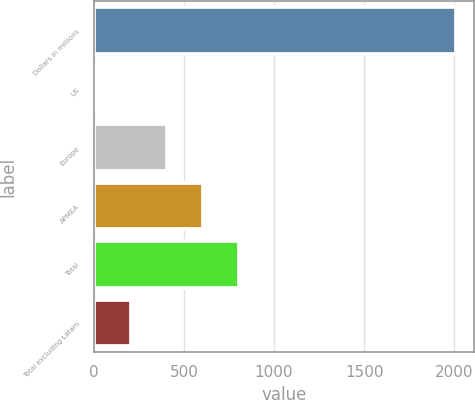Convert chart to OTSL. <chart><loc_0><loc_0><loc_500><loc_500><bar_chart><fcel>Dollars in millions<fcel>US<fcel>Europe<fcel>APMEA<fcel>Total<fcel>Total excluding Latam<nl><fcel>2008<fcel>8<fcel>408<fcel>608<fcel>808<fcel>208<nl></chart> 